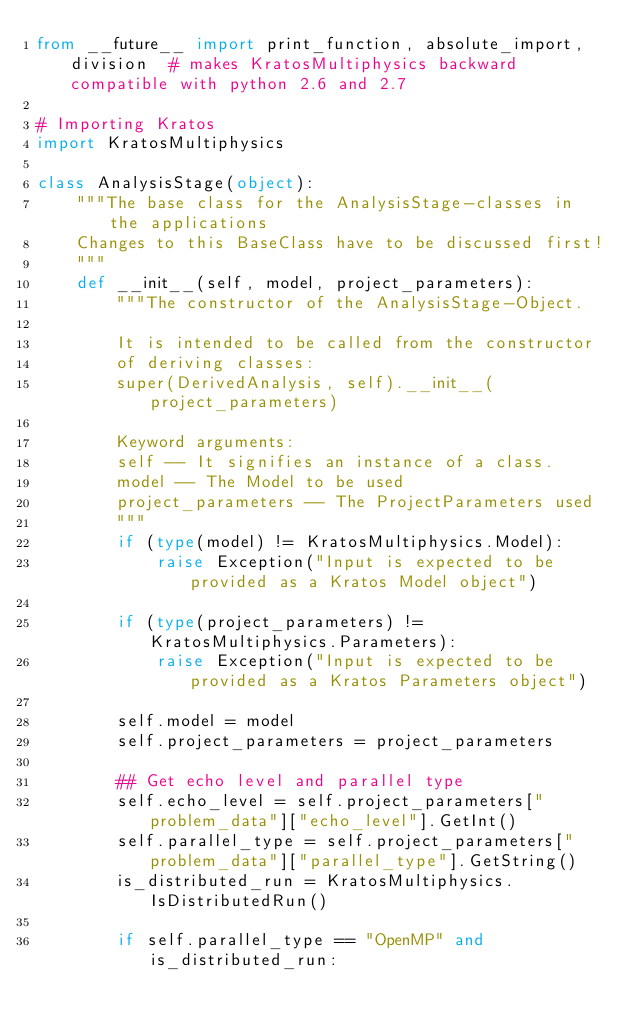Convert code to text. <code><loc_0><loc_0><loc_500><loc_500><_Python_>from __future__ import print_function, absolute_import, division  # makes KratosMultiphysics backward compatible with python 2.6 and 2.7

# Importing Kratos
import KratosMultiphysics

class AnalysisStage(object):
    """The base class for the AnalysisStage-classes in the applications
    Changes to this BaseClass have to be discussed first!
    """
    def __init__(self, model, project_parameters):
        """The constructor of the AnalysisStage-Object.

        It is intended to be called from the constructor
        of deriving classes:
        super(DerivedAnalysis, self).__init__(project_parameters)

        Keyword arguments:
        self -- It signifies an instance of a class.
        model -- The Model to be used
        project_parameters -- The ProjectParameters used
        """
        if (type(model) != KratosMultiphysics.Model):
            raise Exception("Input is expected to be provided as a Kratos Model object")

        if (type(project_parameters) != KratosMultiphysics.Parameters):
            raise Exception("Input is expected to be provided as a Kratos Parameters object")

        self.model = model
        self.project_parameters = project_parameters

        ## Get echo level and parallel type
        self.echo_level = self.project_parameters["problem_data"]["echo_level"].GetInt()
        self.parallel_type = self.project_parameters["problem_data"]["parallel_type"].GetString()
        is_distributed_run = KratosMultiphysics.IsDistributedRun()

        if self.parallel_type == "OpenMP" and is_distributed_run:</code> 